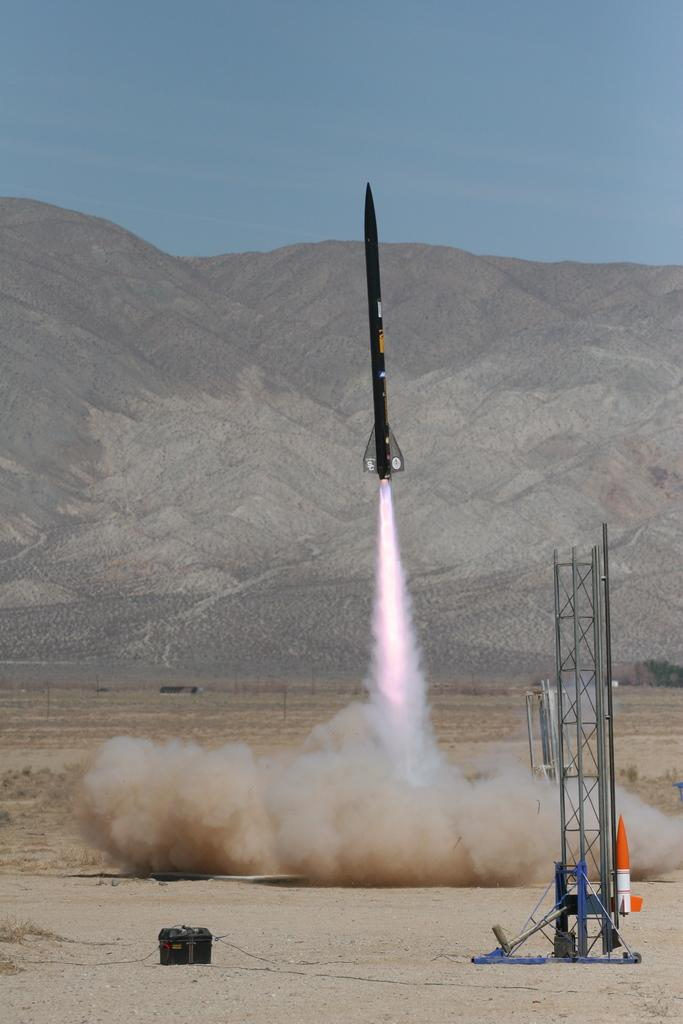What is the main subject of the image? The main subject of the image is a rocket. Are there any other structures or objects in the image? Yes, there is a small tower in the image. What can be seen in the background of the image? There is a mountain and the sky visible in the background of the image. What type of lock can be seen on the button in the image? There is no lock or button present in the image. Can you provide a suggestion for improving the rocket's design based on the image? The provided facts do not offer any information about the rocket's design or potential improvements, so it is not possible to provide a suggestion based on the image. 